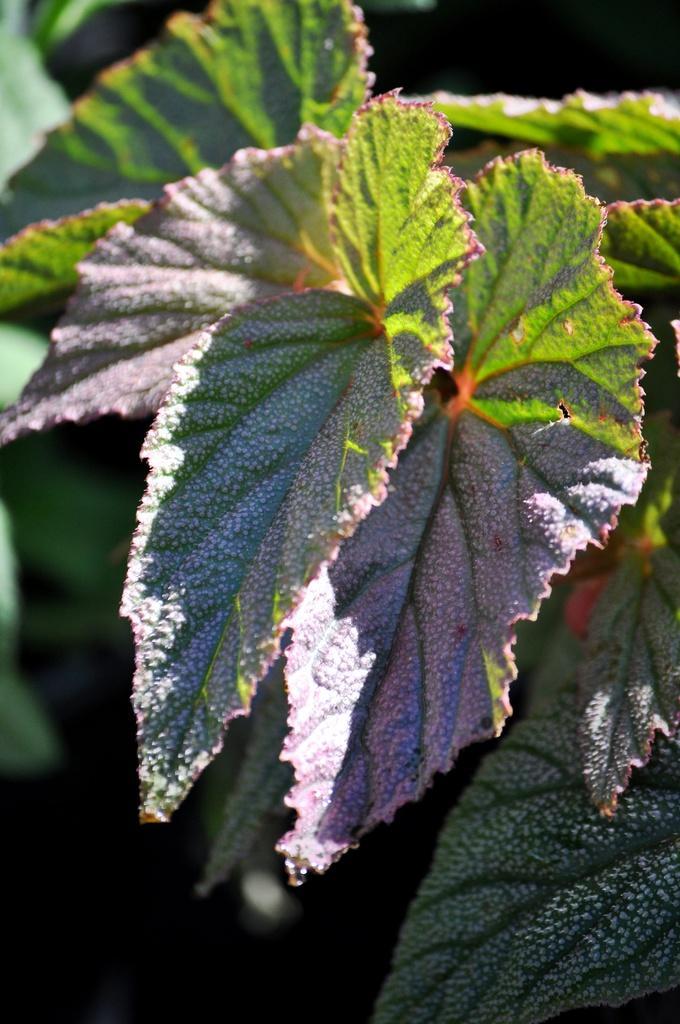How would you summarize this image in a sentence or two? This picture consists of leaves in the image. 